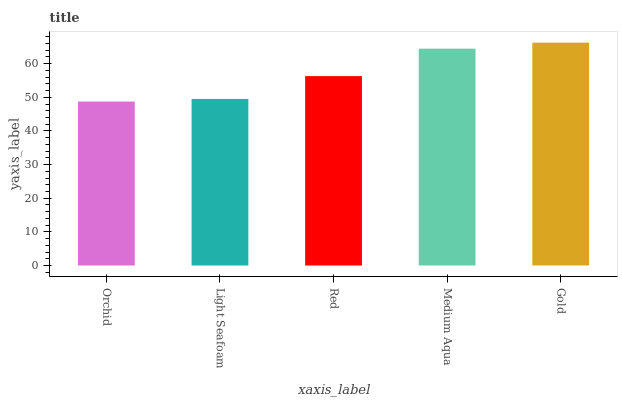Is Orchid the minimum?
Answer yes or no. Yes. Is Gold the maximum?
Answer yes or no. Yes. Is Light Seafoam the minimum?
Answer yes or no. No. Is Light Seafoam the maximum?
Answer yes or no. No. Is Light Seafoam greater than Orchid?
Answer yes or no. Yes. Is Orchid less than Light Seafoam?
Answer yes or no. Yes. Is Orchid greater than Light Seafoam?
Answer yes or no. No. Is Light Seafoam less than Orchid?
Answer yes or no. No. Is Red the high median?
Answer yes or no. Yes. Is Red the low median?
Answer yes or no. Yes. Is Light Seafoam the high median?
Answer yes or no. No. Is Gold the low median?
Answer yes or no. No. 